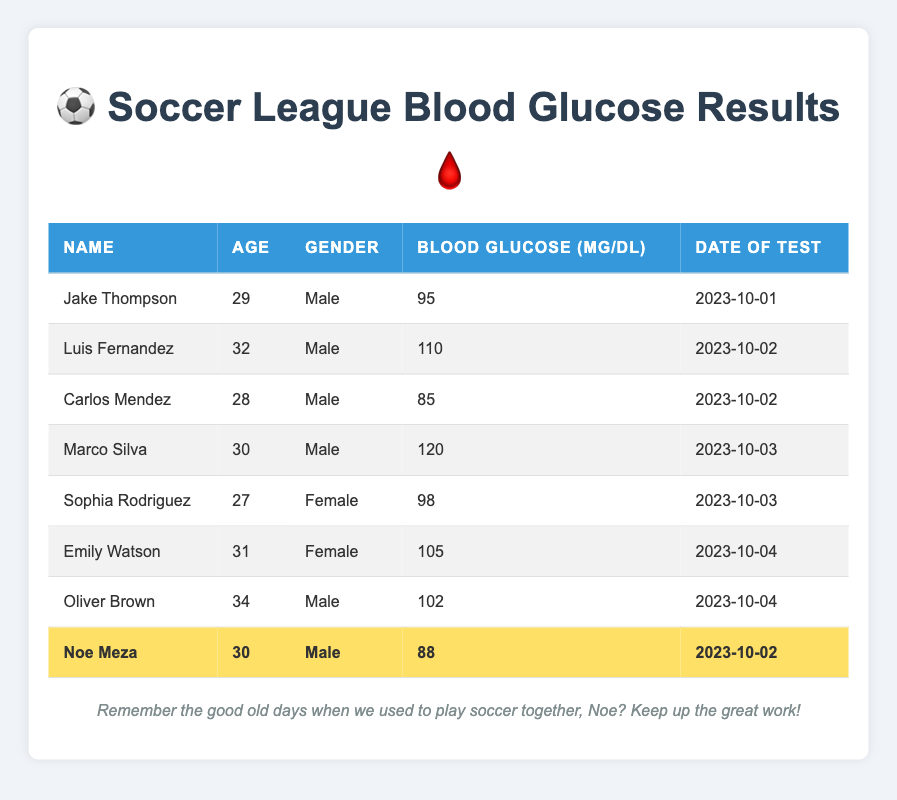What is the Blood Glucose Level of Noe Meza? The table lists Noe Meza's Blood Glucose Level under the column labeled "Blood Glucose (mg/dL)." His level is displayed as 88.
Answer: 88 Which individual has the highest Blood Glucose Level? To find the highest Blood Glucose Level, we scan through the "Blood Glucose (mg/dL)" column and identify Marco Silva, who has a level of 120, which is the largest compared to others.
Answer: Marco Silva What is the average Blood Glucose Level of all males in the table? The Blood Glucose Levels of males are 95, 110, 85, 120, and 88. We sum these values (95 + 110 + 85 + 120 + 88 = 498) and divide by the number of males (5) to get the average: 498/5 = 99.6.
Answer: 99.6 Is Sophia Rodriguez's Blood Glucose Level greater than 100 mg/dL? The table shows Sophia Rodriguez's Blood Glucose Level as 98 mg/dL. This can be directly compared to 100 mg/dL. Since 98 is less than 100, the answer is no.
Answer: No How many individuals have Blood Glucose Levels below 90 mg/dL? We need to check each person's Blood Glucose Level in the table. Only Carlos Mendez (85) and Noe Meza (88) have levels below 90 mg/dL, totaling 2 individuals.
Answer: 2 What is the difference in Blood Glucose Levels between Marco Silva and Oliver Brown? Marco Silva's level is 120 mg/dL, and Oliver Brown's level is 102 mg/dL. The difference is calculated as 120 - 102 = 18.
Answer: 18 Who are the females in the table and what are their Blood Glucose Levels? The table lists two females: Sophia Rodriguez and Emily Watson with Blood Glucose Levels of 98 and 105 mg/dL, respectively. Therefore, the females are Sophia Rodriguez (98) and Emily Watson (105).
Answer: Sophia Rodriguez (98), Emily Watson (105) What is the Blood Glucose Level of the youngest individual in the table? The youngest individual is Carlos Mendez, who is 28 years old. His Blood Glucose Level is listed as 85 mg/dL.
Answer: 85 How many individuals had their Blood Glucose tested on October 2, 2023? On October 2, 2023, three individuals had their Blood Glucose tested, which are Luis Fernandez, Carlos Mendez, and Noe Meza.
Answer: 3 